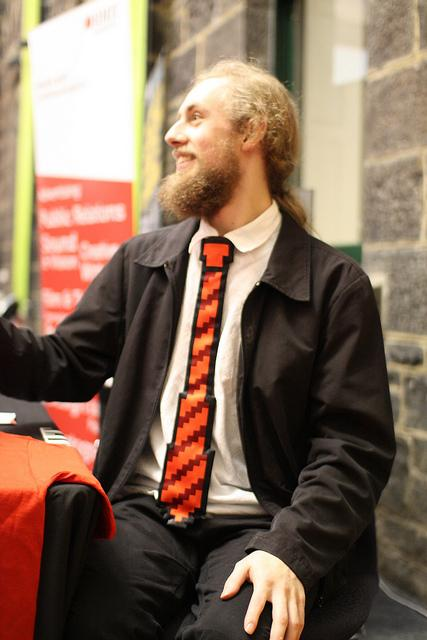What unusual design does his tie have? pixelated 